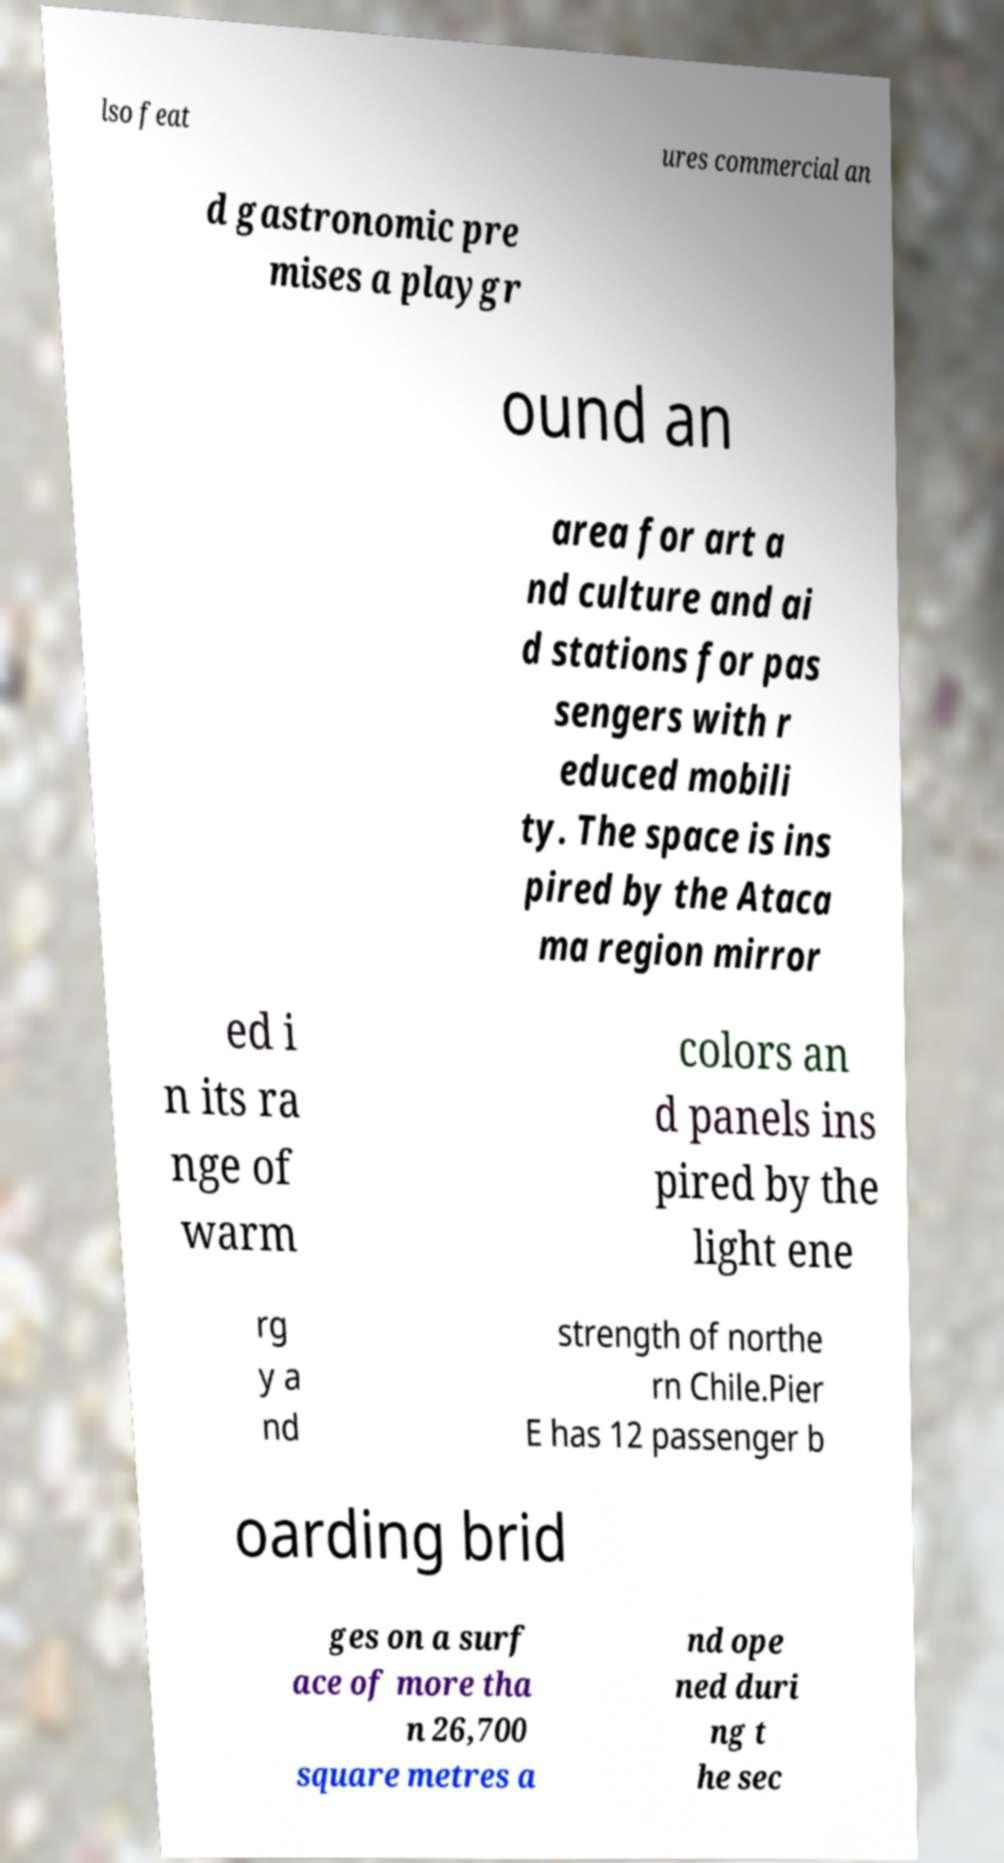Could you extract and type out the text from this image? lso feat ures commercial an d gastronomic pre mises a playgr ound an area for art a nd culture and ai d stations for pas sengers with r educed mobili ty. The space is ins pired by the Ataca ma region mirror ed i n its ra nge of warm colors an d panels ins pired by the light ene rg y a nd strength of northe rn Chile.Pier E has 12 passenger b oarding brid ges on a surf ace of more tha n 26,700 square metres a nd ope ned duri ng t he sec 